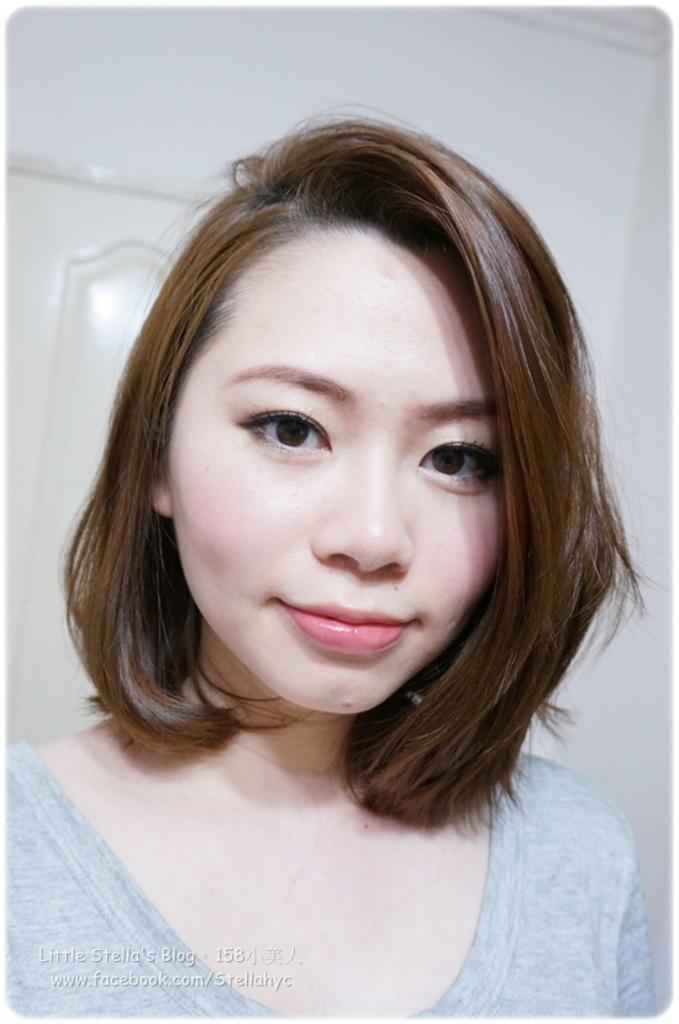Can you describe this image briefly? As we can see in the image in the front there is a woman wearing grey color dress. In the background there is white color wall and a door. 